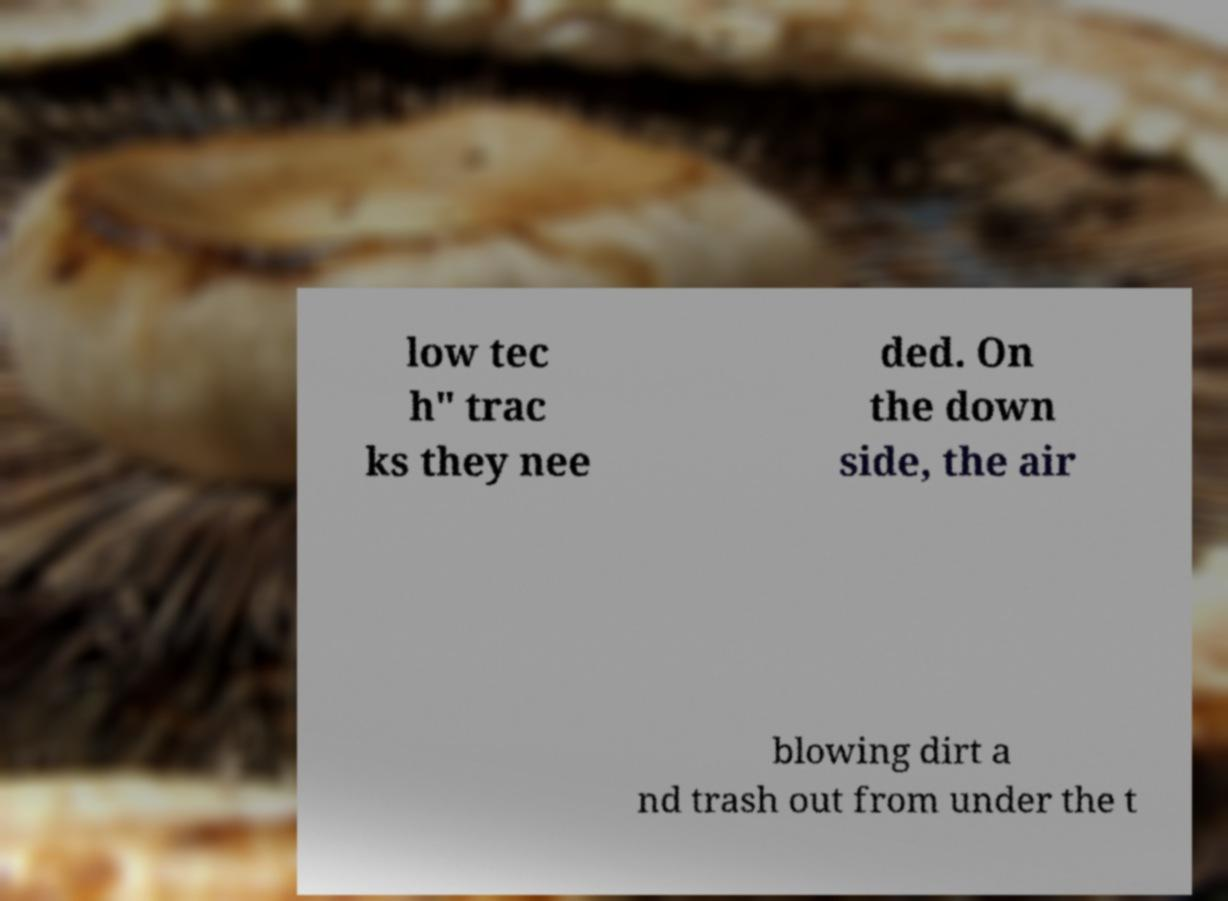Can you accurately transcribe the text from the provided image for me? low tec h" trac ks they nee ded. On the down side, the air blowing dirt a nd trash out from under the t 